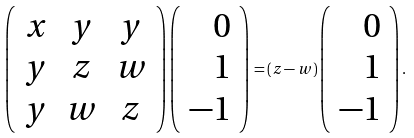<formula> <loc_0><loc_0><loc_500><loc_500>\left ( \begin{array} { c c c } x & y & y \\ y & z & w \\ y & w & z \end{array} \right ) \left ( \begin{array} { r } 0 \\ 1 \\ - 1 \end{array} \right ) = ( z - w ) \left ( \begin{array} { r } 0 \\ 1 \\ - 1 \end{array} \right ) .</formula> 